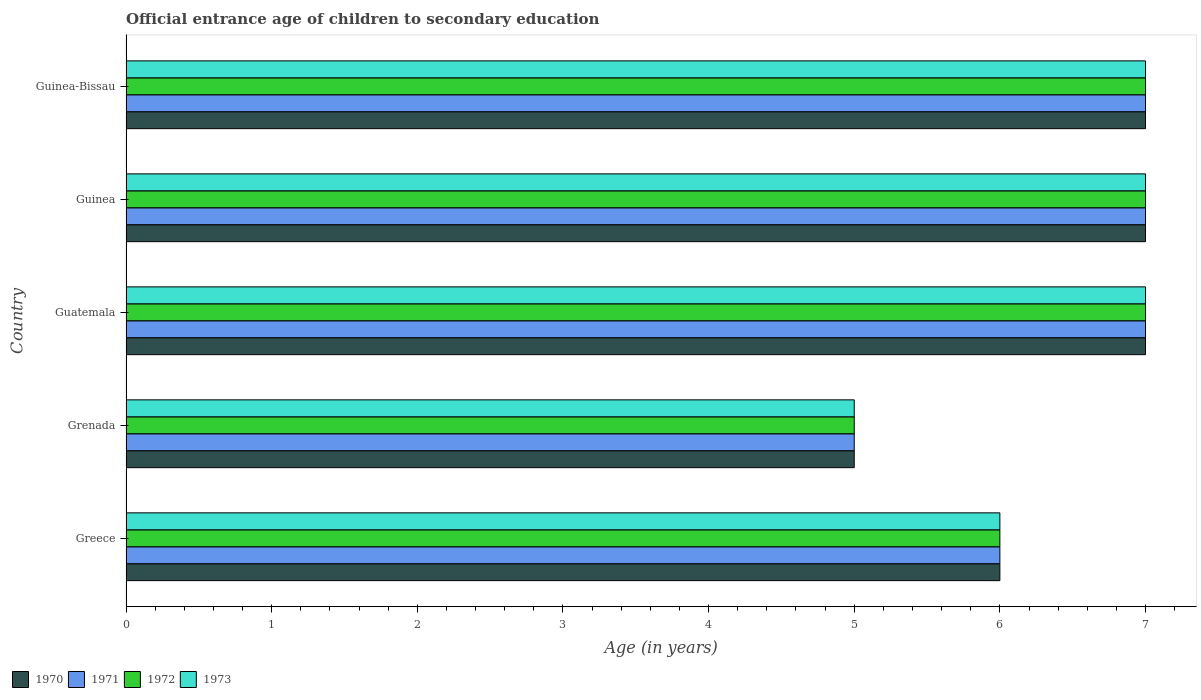How many different coloured bars are there?
Give a very brief answer. 4. How many bars are there on the 3rd tick from the bottom?
Ensure brevity in your answer.  4. What is the label of the 4th group of bars from the top?
Ensure brevity in your answer.  Grenada. In how many cases, is the number of bars for a given country not equal to the number of legend labels?
Make the answer very short. 0. What is the secondary school starting age of children in 1971 in Grenada?
Offer a terse response. 5. Across all countries, what is the maximum secondary school starting age of children in 1970?
Offer a very short reply. 7. Across all countries, what is the minimum secondary school starting age of children in 1970?
Your answer should be compact. 5. In which country was the secondary school starting age of children in 1972 maximum?
Offer a very short reply. Guatemala. In which country was the secondary school starting age of children in 1972 minimum?
Provide a short and direct response. Grenada. What is the total secondary school starting age of children in 1972 in the graph?
Make the answer very short. 32. What is the difference between the secondary school starting age of children in 1972 in Grenada and that in Guatemala?
Offer a terse response. -2. What is the average secondary school starting age of children in 1973 per country?
Provide a succinct answer. 6.4. In how many countries, is the secondary school starting age of children in 1973 greater than 2.8 years?
Your response must be concise. 5. What is the ratio of the secondary school starting age of children in 1973 in Greece to that in Guinea?
Provide a short and direct response. 0.86. Is the difference between the secondary school starting age of children in 1973 in Guatemala and Guinea-Bissau greater than the difference between the secondary school starting age of children in 1971 in Guatemala and Guinea-Bissau?
Your answer should be very brief. No. In how many countries, is the secondary school starting age of children in 1971 greater than the average secondary school starting age of children in 1971 taken over all countries?
Give a very brief answer. 3. What does the 4th bar from the top in Guatemala represents?
Offer a terse response. 1970. What does the 2nd bar from the bottom in Guatemala represents?
Give a very brief answer. 1971. What is the difference between two consecutive major ticks on the X-axis?
Make the answer very short. 1. Does the graph contain any zero values?
Make the answer very short. No. Where does the legend appear in the graph?
Keep it short and to the point. Bottom left. How many legend labels are there?
Provide a short and direct response. 4. What is the title of the graph?
Make the answer very short. Official entrance age of children to secondary education. What is the label or title of the X-axis?
Keep it short and to the point. Age (in years). What is the Age (in years) in 1970 in Greece?
Give a very brief answer. 6. What is the Age (in years) of 1972 in Greece?
Your response must be concise. 6. What is the Age (in years) of 1971 in Grenada?
Your answer should be compact. 5. What is the Age (in years) in 1972 in Grenada?
Make the answer very short. 5. What is the Age (in years) in 1970 in Guatemala?
Give a very brief answer. 7. What is the Age (in years) in 1973 in Guatemala?
Offer a very short reply. 7. What is the Age (in years) in 1970 in Guinea?
Your answer should be very brief. 7. What is the Age (in years) of 1971 in Guinea?
Your answer should be compact. 7. What is the Age (in years) of 1973 in Guinea?
Make the answer very short. 7. What is the Age (in years) of 1970 in Guinea-Bissau?
Offer a very short reply. 7. What is the Age (in years) in 1972 in Guinea-Bissau?
Your answer should be compact. 7. Across all countries, what is the maximum Age (in years) in 1970?
Your response must be concise. 7. Across all countries, what is the maximum Age (in years) of 1971?
Your answer should be very brief. 7. Across all countries, what is the minimum Age (in years) in 1971?
Offer a terse response. 5. What is the total Age (in years) of 1970 in the graph?
Your answer should be very brief. 32. What is the total Age (in years) in 1973 in the graph?
Your answer should be compact. 32. What is the difference between the Age (in years) in 1972 in Greece and that in Grenada?
Keep it short and to the point. 1. What is the difference between the Age (in years) in 1970 in Greece and that in Guatemala?
Your answer should be very brief. -1. What is the difference between the Age (in years) of 1971 in Greece and that in Guatemala?
Give a very brief answer. -1. What is the difference between the Age (in years) in 1973 in Greece and that in Guatemala?
Provide a short and direct response. -1. What is the difference between the Age (in years) of 1970 in Greece and that in Guinea?
Your answer should be compact. -1. What is the difference between the Age (in years) of 1971 in Greece and that in Guinea?
Provide a succinct answer. -1. What is the difference between the Age (in years) of 1972 in Greece and that in Guinea?
Your answer should be very brief. -1. What is the difference between the Age (in years) of 1972 in Greece and that in Guinea-Bissau?
Provide a short and direct response. -1. What is the difference between the Age (in years) of 1973 in Greece and that in Guinea-Bissau?
Your answer should be very brief. -1. What is the difference between the Age (in years) of 1971 in Grenada and that in Guinea?
Offer a very short reply. -2. What is the difference between the Age (in years) of 1973 in Grenada and that in Guinea?
Offer a terse response. -2. What is the difference between the Age (in years) in 1970 in Grenada and that in Guinea-Bissau?
Ensure brevity in your answer.  -2. What is the difference between the Age (in years) of 1973 in Guatemala and that in Guinea?
Offer a terse response. 0. What is the difference between the Age (in years) of 1970 in Guatemala and that in Guinea-Bissau?
Make the answer very short. 0. What is the difference between the Age (in years) of 1971 in Guatemala and that in Guinea-Bissau?
Your answer should be very brief. 0. What is the difference between the Age (in years) of 1972 in Guatemala and that in Guinea-Bissau?
Provide a succinct answer. 0. What is the difference between the Age (in years) of 1972 in Guinea and that in Guinea-Bissau?
Give a very brief answer. 0. What is the difference between the Age (in years) in 1970 in Greece and the Age (in years) in 1971 in Grenada?
Give a very brief answer. 1. What is the difference between the Age (in years) in 1970 in Greece and the Age (in years) in 1973 in Grenada?
Give a very brief answer. 1. What is the difference between the Age (in years) of 1972 in Greece and the Age (in years) of 1973 in Grenada?
Keep it short and to the point. 1. What is the difference between the Age (in years) of 1970 in Greece and the Age (in years) of 1971 in Guatemala?
Offer a terse response. -1. What is the difference between the Age (in years) of 1970 in Greece and the Age (in years) of 1972 in Guatemala?
Make the answer very short. -1. What is the difference between the Age (in years) in 1970 in Greece and the Age (in years) in 1973 in Guatemala?
Your answer should be very brief. -1. What is the difference between the Age (in years) in 1971 in Greece and the Age (in years) in 1972 in Guatemala?
Provide a succinct answer. -1. What is the difference between the Age (in years) of 1972 in Greece and the Age (in years) of 1973 in Guatemala?
Offer a very short reply. -1. What is the difference between the Age (in years) in 1972 in Greece and the Age (in years) in 1973 in Guinea?
Make the answer very short. -1. What is the difference between the Age (in years) of 1970 in Greece and the Age (in years) of 1972 in Guinea-Bissau?
Your answer should be very brief. -1. What is the difference between the Age (in years) in 1970 in Greece and the Age (in years) in 1973 in Guinea-Bissau?
Give a very brief answer. -1. What is the difference between the Age (in years) of 1971 in Greece and the Age (in years) of 1972 in Guinea-Bissau?
Ensure brevity in your answer.  -1. What is the difference between the Age (in years) of 1972 in Greece and the Age (in years) of 1973 in Guinea-Bissau?
Your answer should be very brief. -1. What is the difference between the Age (in years) of 1970 in Grenada and the Age (in years) of 1972 in Guatemala?
Offer a very short reply. -2. What is the difference between the Age (in years) in 1970 in Grenada and the Age (in years) in 1973 in Guatemala?
Keep it short and to the point. -2. What is the difference between the Age (in years) of 1971 in Grenada and the Age (in years) of 1972 in Guatemala?
Provide a short and direct response. -2. What is the difference between the Age (in years) of 1972 in Grenada and the Age (in years) of 1973 in Guatemala?
Ensure brevity in your answer.  -2. What is the difference between the Age (in years) of 1970 in Grenada and the Age (in years) of 1971 in Guinea?
Your response must be concise. -2. What is the difference between the Age (in years) of 1970 in Grenada and the Age (in years) of 1973 in Guinea?
Provide a succinct answer. -2. What is the difference between the Age (in years) of 1972 in Grenada and the Age (in years) of 1973 in Guinea?
Offer a very short reply. -2. What is the difference between the Age (in years) of 1970 in Grenada and the Age (in years) of 1971 in Guinea-Bissau?
Ensure brevity in your answer.  -2. What is the difference between the Age (in years) of 1970 in Grenada and the Age (in years) of 1973 in Guinea-Bissau?
Make the answer very short. -2. What is the difference between the Age (in years) in 1972 in Grenada and the Age (in years) in 1973 in Guinea-Bissau?
Provide a succinct answer. -2. What is the difference between the Age (in years) of 1970 in Guatemala and the Age (in years) of 1972 in Guinea?
Offer a terse response. 0. What is the difference between the Age (in years) in 1970 in Guatemala and the Age (in years) in 1973 in Guinea?
Provide a succinct answer. 0. What is the difference between the Age (in years) of 1971 in Guatemala and the Age (in years) of 1972 in Guinea?
Offer a very short reply. 0. What is the difference between the Age (in years) of 1971 in Guatemala and the Age (in years) of 1973 in Guinea?
Your answer should be compact. 0. What is the difference between the Age (in years) of 1972 in Guatemala and the Age (in years) of 1973 in Guinea?
Your answer should be compact. 0. What is the difference between the Age (in years) in 1970 in Guatemala and the Age (in years) in 1971 in Guinea-Bissau?
Provide a short and direct response. 0. What is the difference between the Age (in years) of 1970 in Guatemala and the Age (in years) of 1973 in Guinea-Bissau?
Offer a terse response. 0. What is the difference between the Age (in years) in 1971 in Guatemala and the Age (in years) in 1972 in Guinea-Bissau?
Your response must be concise. 0. What is the difference between the Age (in years) in 1971 in Guatemala and the Age (in years) in 1973 in Guinea-Bissau?
Your response must be concise. 0. What is the difference between the Age (in years) in 1972 in Guatemala and the Age (in years) in 1973 in Guinea-Bissau?
Make the answer very short. 0. What is the difference between the Age (in years) in 1970 in Guinea and the Age (in years) in 1972 in Guinea-Bissau?
Your answer should be very brief. 0. What is the difference between the Age (in years) of 1971 in Guinea and the Age (in years) of 1972 in Guinea-Bissau?
Your answer should be very brief. 0. What is the difference between the Age (in years) of 1971 in Guinea and the Age (in years) of 1973 in Guinea-Bissau?
Offer a terse response. 0. What is the difference between the Age (in years) of 1972 in Guinea and the Age (in years) of 1973 in Guinea-Bissau?
Provide a short and direct response. 0. What is the average Age (in years) in 1970 per country?
Offer a terse response. 6.4. What is the average Age (in years) of 1971 per country?
Make the answer very short. 6.4. What is the difference between the Age (in years) of 1970 and Age (in years) of 1971 in Greece?
Provide a succinct answer. 0. What is the difference between the Age (in years) of 1970 and Age (in years) of 1973 in Greece?
Make the answer very short. 0. What is the difference between the Age (in years) in 1971 and Age (in years) in 1972 in Greece?
Your answer should be very brief. 0. What is the difference between the Age (in years) in 1971 and Age (in years) in 1973 in Greece?
Your response must be concise. 0. What is the difference between the Age (in years) in 1972 and Age (in years) in 1973 in Greece?
Offer a very short reply. 0. What is the difference between the Age (in years) in 1970 and Age (in years) in 1971 in Grenada?
Provide a short and direct response. 0. What is the difference between the Age (in years) in 1970 and Age (in years) in 1972 in Grenada?
Give a very brief answer. 0. What is the difference between the Age (in years) in 1971 and Age (in years) in 1972 in Grenada?
Offer a terse response. 0. What is the difference between the Age (in years) in 1971 and Age (in years) in 1973 in Grenada?
Offer a very short reply. 0. What is the difference between the Age (in years) of 1970 and Age (in years) of 1972 in Guatemala?
Offer a very short reply. 0. What is the difference between the Age (in years) of 1971 and Age (in years) of 1972 in Guatemala?
Provide a succinct answer. 0. What is the difference between the Age (in years) in 1971 and Age (in years) in 1973 in Guatemala?
Offer a terse response. 0. What is the difference between the Age (in years) of 1972 and Age (in years) of 1973 in Guatemala?
Make the answer very short. 0. What is the difference between the Age (in years) of 1970 and Age (in years) of 1971 in Guinea?
Your answer should be very brief. 0. What is the difference between the Age (in years) of 1970 and Age (in years) of 1972 in Guinea?
Your response must be concise. 0. What is the difference between the Age (in years) of 1970 and Age (in years) of 1973 in Guinea?
Offer a very short reply. 0. What is the difference between the Age (in years) of 1971 and Age (in years) of 1972 in Guinea?
Provide a succinct answer. 0. What is the difference between the Age (in years) in 1971 and Age (in years) in 1973 in Guinea?
Give a very brief answer. 0. What is the difference between the Age (in years) in 1972 and Age (in years) in 1973 in Guinea?
Your answer should be very brief. 0. What is the difference between the Age (in years) of 1970 and Age (in years) of 1973 in Guinea-Bissau?
Offer a very short reply. 0. What is the difference between the Age (in years) of 1972 and Age (in years) of 1973 in Guinea-Bissau?
Your answer should be compact. 0. What is the ratio of the Age (in years) of 1973 in Greece to that in Grenada?
Your answer should be compact. 1.2. What is the ratio of the Age (in years) of 1970 in Greece to that in Guatemala?
Offer a very short reply. 0.86. What is the ratio of the Age (in years) in 1971 in Greece to that in Guatemala?
Your answer should be very brief. 0.86. What is the ratio of the Age (in years) of 1970 in Greece to that in Guinea?
Offer a terse response. 0.86. What is the ratio of the Age (in years) of 1971 in Greece to that in Guinea?
Give a very brief answer. 0.86. What is the ratio of the Age (in years) of 1973 in Greece to that in Guinea?
Offer a terse response. 0.86. What is the ratio of the Age (in years) of 1970 in Greece to that in Guinea-Bissau?
Your answer should be compact. 0.86. What is the ratio of the Age (in years) in 1971 in Greece to that in Guinea-Bissau?
Your answer should be very brief. 0.86. What is the ratio of the Age (in years) in 1972 in Greece to that in Guinea-Bissau?
Offer a very short reply. 0.86. What is the ratio of the Age (in years) in 1973 in Greece to that in Guinea-Bissau?
Make the answer very short. 0.86. What is the ratio of the Age (in years) in 1971 in Grenada to that in Guatemala?
Your response must be concise. 0.71. What is the ratio of the Age (in years) in 1972 in Grenada to that in Guatemala?
Provide a succinct answer. 0.71. What is the ratio of the Age (in years) of 1973 in Grenada to that in Guatemala?
Offer a terse response. 0.71. What is the ratio of the Age (in years) of 1970 in Grenada to that in Guinea?
Provide a short and direct response. 0.71. What is the ratio of the Age (in years) in 1971 in Grenada to that in Guinea?
Your answer should be very brief. 0.71. What is the ratio of the Age (in years) of 1970 in Grenada to that in Guinea-Bissau?
Your answer should be compact. 0.71. What is the ratio of the Age (in years) in 1972 in Grenada to that in Guinea-Bissau?
Provide a short and direct response. 0.71. What is the ratio of the Age (in years) of 1972 in Guatemala to that in Guinea?
Provide a short and direct response. 1. What is the ratio of the Age (in years) in 1973 in Guatemala to that in Guinea?
Provide a succinct answer. 1. What is the ratio of the Age (in years) of 1970 in Guatemala to that in Guinea-Bissau?
Offer a terse response. 1. What is the ratio of the Age (in years) of 1970 in Guinea to that in Guinea-Bissau?
Provide a short and direct response. 1. What is the ratio of the Age (in years) of 1972 in Guinea to that in Guinea-Bissau?
Make the answer very short. 1. What is the difference between the highest and the second highest Age (in years) in 1972?
Provide a succinct answer. 0. 